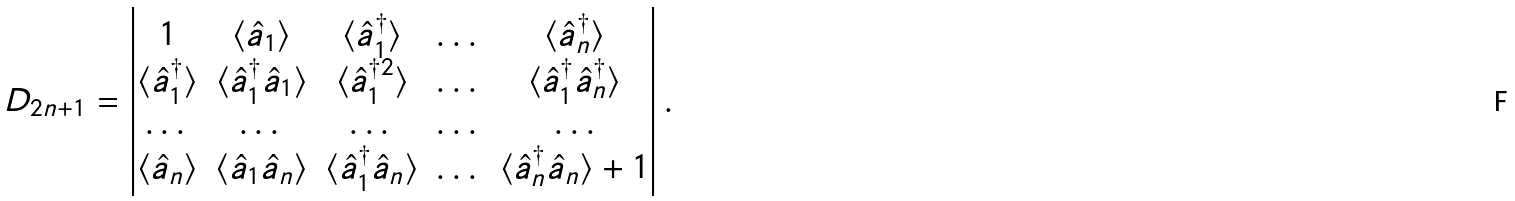Convert formula to latex. <formula><loc_0><loc_0><loc_500><loc_500>D _ { 2 n + 1 } = \begin{vmatrix} 1 & \langle \hat { a } _ { 1 } \rangle & \langle \hat { a } ^ { \dagger } _ { 1 } \rangle & \dots & \langle \hat { a } ^ { \dagger } _ { n } \rangle \\ \langle \hat { a } ^ { \dagger } _ { 1 } \rangle & \langle \hat { a } ^ { \dagger } _ { 1 } \hat { a } _ { 1 } \rangle & \langle \hat { a } ^ { \dagger 2 } _ { 1 } \rangle & \dots & \langle \hat { a } ^ { \dagger } _ { 1 } \hat { a } ^ { \dagger } _ { n } \rangle \\ \dots & \dots & \dots & \dots & \dots \\ \langle \hat { a } _ { n } \rangle & \langle \hat { a } _ { 1 } \hat { a } _ { n } \rangle & \langle \hat { a } ^ { \dagger } _ { 1 } \hat { a } _ { n } \rangle & \dots & \langle \hat { a } ^ { \dagger } _ { n } \hat { a } _ { n } \rangle + 1 \end{vmatrix} .</formula> 